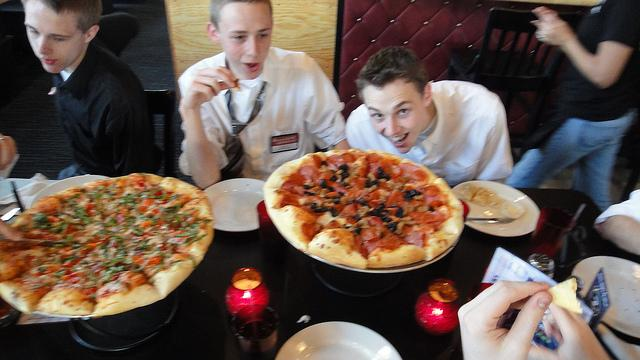What setting is the outfit of the boy sitting in the middle usually found? Please explain your reasoning. office. He is wearing a tie. 